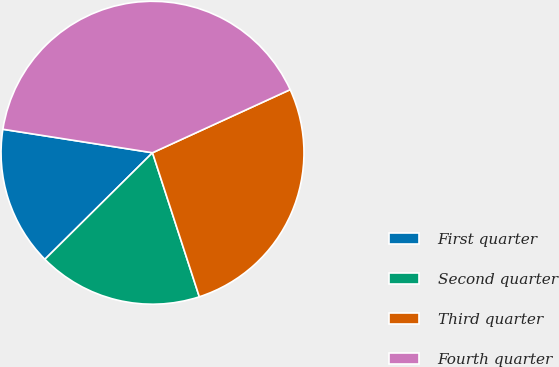Convert chart. <chart><loc_0><loc_0><loc_500><loc_500><pie_chart><fcel>First quarter<fcel>Second quarter<fcel>Third quarter<fcel>Fourth quarter<nl><fcel>14.9%<fcel>17.58%<fcel>26.84%<fcel>40.68%<nl></chart> 